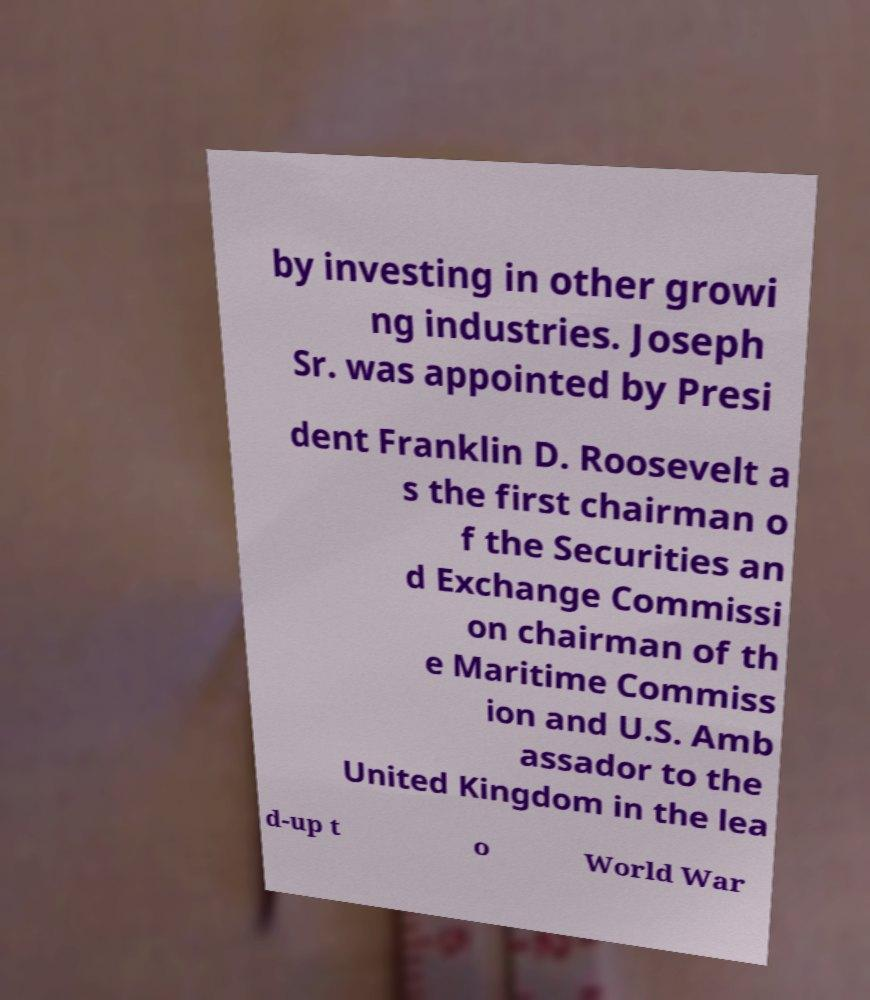Can you accurately transcribe the text from the provided image for me? by investing in other growi ng industries. Joseph Sr. was appointed by Presi dent Franklin D. Roosevelt a s the first chairman o f the Securities an d Exchange Commissi on chairman of th e Maritime Commiss ion and U.S. Amb assador to the United Kingdom in the lea d-up t o World War 